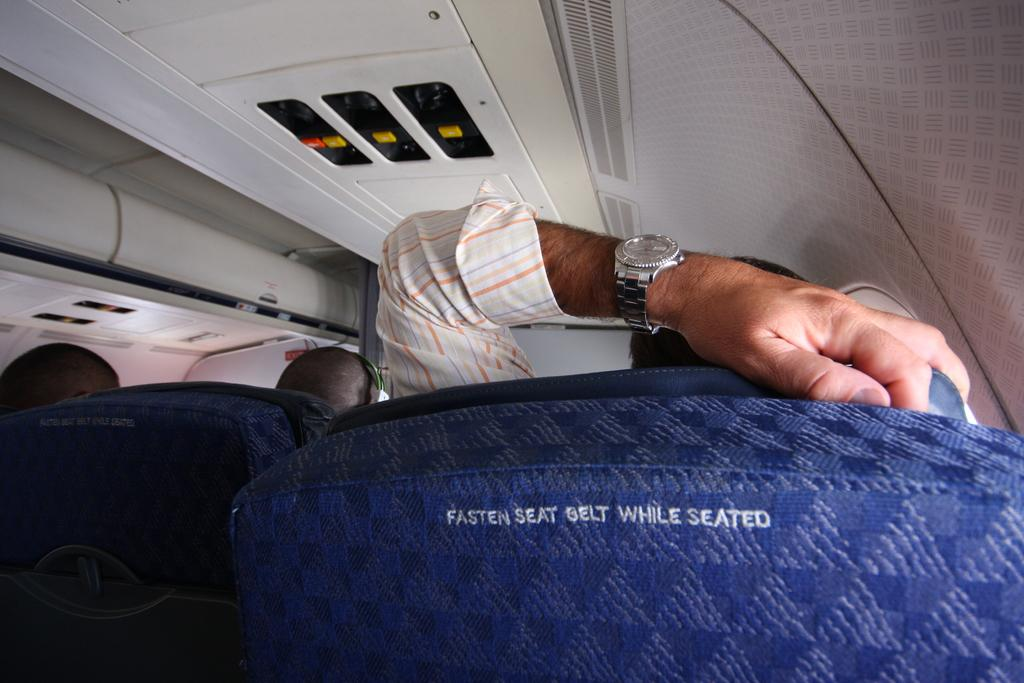<image>
Offer a succinct explanation of the picture presented. A chair that says to fasten seat belt while seated 